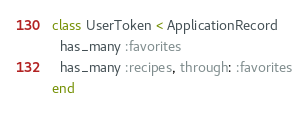<code> <loc_0><loc_0><loc_500><loc_500><_Ruby_>class UserToken < ApplicationRecord
  has_many :favorites
  has_many :recipes, through: :favorites
end
</code> 